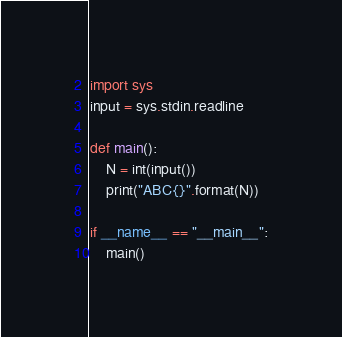<code> <loc_0><loc_0><loc_500><loc_500><_Python_>import sys
input = sys.stdin.readline

def main():
    N = int(input())
    print("ABC{}".format(N))

if __name__ == "__main__":
    main()</code> 